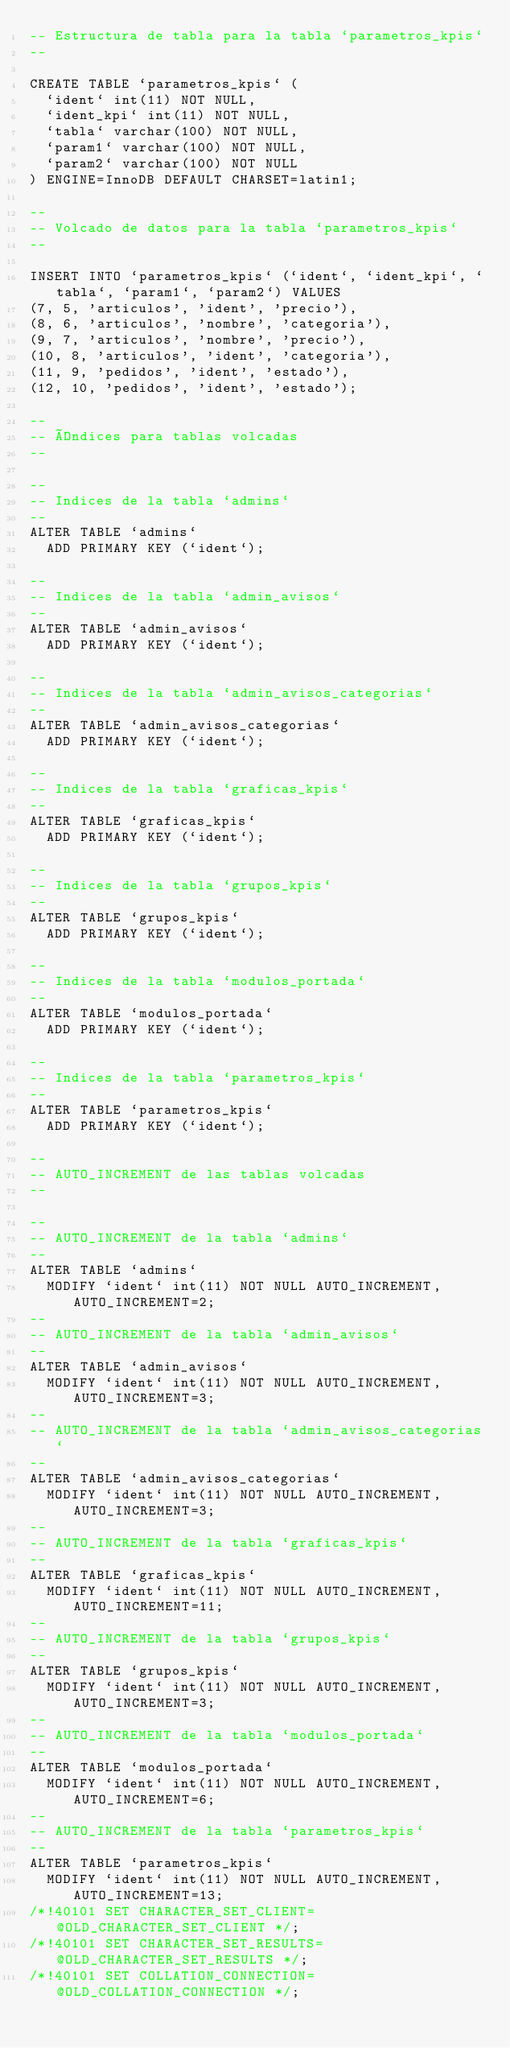<code> <loc_0><loc_0><loc_500><loc_500><_SQL_>-- Estructura de tabla para la tabla `parametros_kpis`
--

CREATE TABLE `parametros_kpis` (
  `ident` int(11) NOT NULL,
  `ident_kpi` int(11) NOT NULL,
  `tabla` varchar(100) NOT NULL,
  `param1` varchar(100) NOT NULL,
  `param2` varchar(100) NOT NULL
) ENGINE=InnoDB DEFAULT CHARSET=latin1;

--
-- Volcado de datos para la tabla `parametros_kpis`
--

INSERT INTO `parametros_kpis` (`ident`, `ident_kpi`, `tabla`, `param1`, `param2`) VALUES
(7, 5, 'articulos', 'ident', 'precio'),
(8, 6, 'articulos', 'nombre', 'categoria'),
(9, 7, 'articulos', 'nombre', 'precio'),
(10, 8, 'articulos', 'ident', 'categoria'),
(11, 9, 'pedidos', 'ident', 'estado'),
(12, 10, 'pedidos', 'ident', 'estado');

--
-- Índices para tablas volcadas
--

--
-- Indices de la tabla `admins`
--
ALTER TABLE `admins`
  ADD PRIMARY KEY (`ident`);

--
-- Indices de la tabla `admin_avisos`
--
ALTER TABLE `admin_avisos`
  ADD PRIMARY KEY (`ident`);

--
-- Indices de la tabla `admin_avisos_categorias`
--
ALTER TABLE `admin_avisos_categorias`
  ADD PRIMARY KEY (`ident`);

--
-- Indices de la tabla `graficas_kpis`
--
ALTER TABLE `graficas_kpis`
  ADD PRIMARY KEY (`ident`);

--
-- Indices de la tabla `grupos_kpis`
--
ALTER TABLE `grupos_kpis`
  ADD PRIMARY KEY (`ident`);

--
-- Indices de la tabla `modulos_portada`
--
ALTER TABLE `modulos_portada`
  ADD PRIMARY KEY (`ident`);

--
-- Indices de la tabla `parametros_kpis`
--
ALTER TABLE `parametros_kpis`
  ADD PRIMARY KEY (`ident`);

--
-- AUTO_INCREMENT de las tablas volcadas
--

--
-- AUTO_INCREMENT de la tabla `admins`
--
ALTER TABLE `admins`
  MODIFY `ident` int(11) NOT NULL AUTO_INCREMENT, AUTO_INCREMENT=2;
--
-- AUTO_INCREMENT de la tabla `admin_avisos`
--
ALTER TABLE `admin_avisos`
  MODIFY `ident` int(11) NOT NULL AUTO_INCREMENT, AUTO_INCREMENT=3;
--
-- AUTO_INCREMENT de la tabla `admin_avisos_categorias`
--
ALTER TABLE `admin_avisos_categorias`
  MODIFY `ident` int(11) NOT NULL AUTO_INCREMENT, AUTO_INCREMENT=3;
--
-- AUTO_INCREMENT de la tabla `graficas_kpis`
--
ALTER TABLE `graficas_kpis`
  MODIFY `ident` int(11) NOT NULL AUTO_INCREMENT, AUTO_INCREMENT=11;
--
-- AUTO_INCREMENT de la tabla `grupos_kpis`
--
ALTER TABLE `grupos_kpis`
  MODIFY `ident` int(11) NOT NULL AUTO_INCREMENT, AUTO_INCREMENT=3;
--
-- AUTO_INCREMENT de la tabla `modulos_portada`
--
ALTER TABLE `modulos_portada`
  MODIFY `ident` int(11) NOT NULL AUTO_INCREMENT, AUTO_INCREMENT=6;
--
-- AUTO_INCREMENT de la tabla `parametros_kpis`
--
ALTER TABLE `parametros_kpis`
  MODIFY `ident` int(11) NOT NULL AUTO_INCREMENT, AUTO_INCREMENT=13;
/*!40101 SET CHARACTER_SET_CLIENT=@OLD_CHARACTER_SET_CLIENT */;
/*!40101 SET CHARACTER_SET_RESULTS=@OLD_CHARACTER_SET_RESULTS */;
/*!40101 SET COLLATION_CONNECTION=@OLD_COLLATION_CONNECTION */;
</code> 